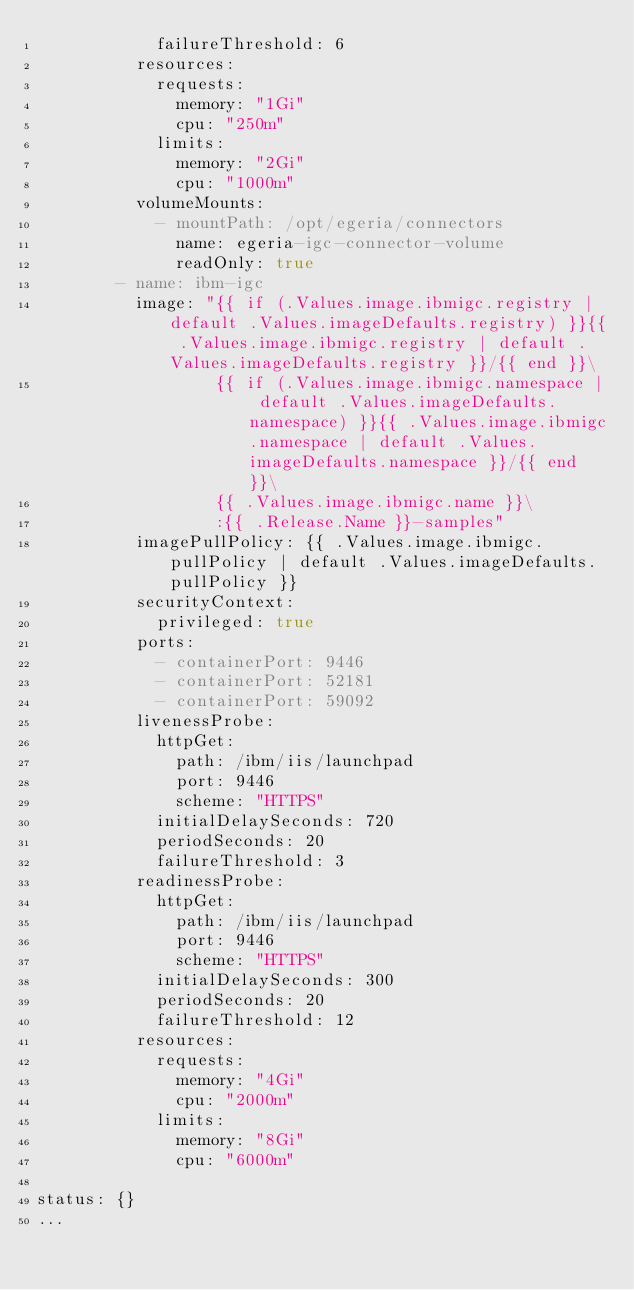<code> <loc_0><loc_0><loc_500><loc_500><_YAML_>            failureThreshold: 6
          resources:
            requests:
              memory: "1Gi"
              cpu: "250m"
            limits:
              memory: "2Gi"
              cpu: "1000m"
          volumeMounts:
            - mountPath: /opt/egeria/connectors
              name: egeria-igc-connector-volume
              readOnly: true
        - name: ibm-igc
          image: "{{ if (.Values.image.ibmigc.registry | default .Values.imageDefaults.registry) }}{{ .Values.image.ibmigc.registry | default .Values.imageDefaults.registry }}/{{ end }}\
                  {{ if (.Values.image.ibmigc.namespace | default .Values.imageDefaults.namespace) }}{{ .Values.image.ibmigc.namespace | default .Values.imageDefaults.namespace }}/{{ end }}\
                  {{ .Values.image.ibmigc.name }}\
                  :{{ .Release.Name }}-samples"
          imagePullPolicy: {{ .Values.image.ibmigc.pullPolicy | default .Values.imageDefaults.pullPolicy }}
          securityContext:
            privileged: true
          ports:
            - containerPort: 9446
            - containerPort: 52181
            - containerPort: 59092
          livenessProbe:
            httpGet:
              path: /ibm/iis/launchpad
              port: 9446
              scheme: "HTTPS"
            initialDelaySeconds: 720
            periodSeconds: 20
            failureThreshold: 3
          readinessProbe:
            httpGet:
              path: /ibm/iis/launchpad
              port: 9446
              scheme: "HTTPS"
            initialDelaySeconds: 300
            periodSeconds: 20
            failureThreshold: 12
          resources:
            requests:
              memory: "4Gi"
              cpu: "2000m"
            limits:
              memory: "8Gi"
              cpu: "6000m"

status: {}
...
</code> 